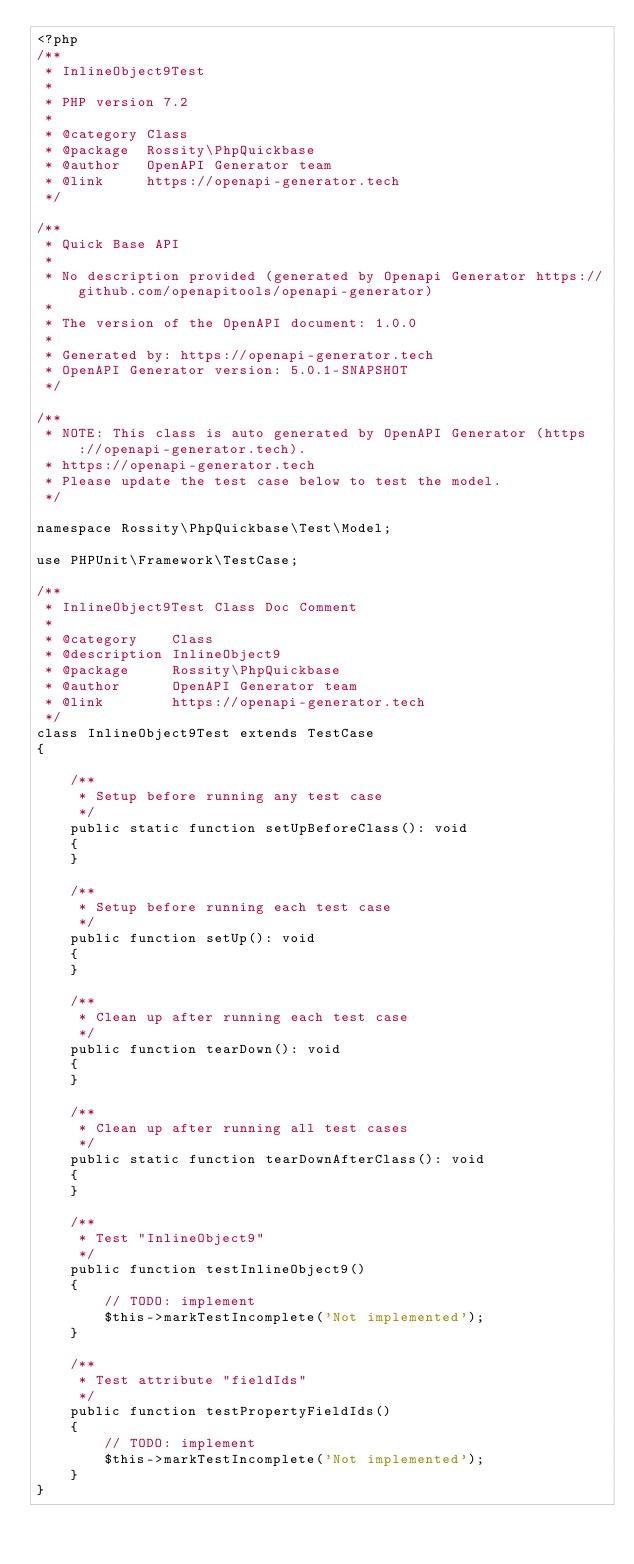<code> <loc_0><loc_0><loc_500><loc_500><_PHP_><?php
/**
 * InlineObject9Test
 *
 * PHP version 7.2
 *
 * @category Class
 * @package  Rossity\PhpQuickbase
 * @author   OpenAPI Generator team
 * @link     https://openapi-generator.tech
 */

/**
 * Quick Base API
 *
 * No description provided (generated by Openapi Generator https://github.com/openapitools/openapi-generator)
 *
 * The version of the OpenAPI document: 1.0.0
 * 
 * Generated by: https://openapi-generator.tech
 * OpenAPI Generator version: 5.0.1-SNAPSHOT
 */

/**
 * NOTE: This class is auto generated by OpenAPI Generator (https://openapi-generator.tech).
 * https://openapi-generator.tech
 * Please update the test case below to test the model.
 */

namespace Rossity\PhpQuickbase\Test\Model;

use PHPUnit\Framework\TestCase;

/**
 * InlineObject9Test Class Doc Comment
 *
 * @category    Class
 * @description InlineObject9
 * @package     Rossity\PhpQuickbase
 * @author      OpenAPI Generator team
 * @link        https://openapi-generator.tech
 */
class InlineObject9Test extends TestCase
{

    /**
     * Setup before running any test case
     */
    public static function setUpBeforeClass(): void
    {
    }

    /**
     * Setup before running each test case
     */
    public function setUp(): void
    {
    }

    /**
     * Clean up after running each test case
     */
    public function tearDown(): void
    {
    }

    /**
     * Clean up after running all test cases
     */
    public static function tearDownAfterClass(): void
    {
    }

    /**
     * Test "InlineObject9"
     */
    public function testInlineObject9()
    {
        // TODO: implement
        $this->markTestIncomplete('Not implemented');
    }

    /**
     * Test attribute "fieldIds"
     */
    public function testPropertyFieldIds()
    {
        // TODO: implement
        $this->markTestIncomplete('Not implemented');
    }
}
</code> 